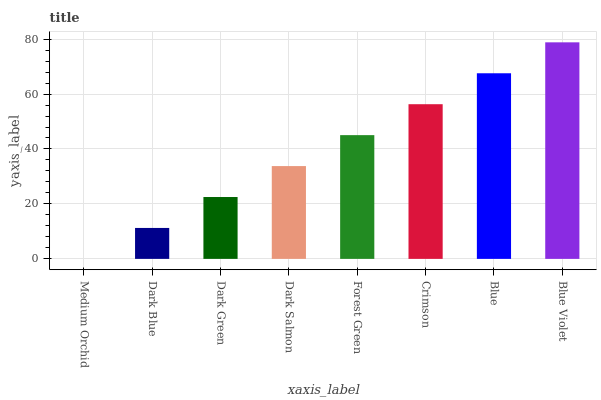Is Medium Orchid the minimum?
Answer yes or no. Yes. Is Blue Violet the maximum?
Answer yes or no. Yes. Is Dark Blue the minimum?
Answer yes or no. No. Is Dark Blue the maximum?
Answer yes or no. No. Is Dark Blue greater than Medium Orchid?
Answer yes or no. Yes. Is Medium Orchid less than Dark Blue?
Answer yes or no. Yes. Is Medium Orchid greater than Dark Blue?
Answer yes or no. No. Is Dark Blue less than Medium Orchid?
Answer yes or no. No. Is Forest Green the high median?
Answer yes or no. Yes. Is Dark Salmon the low median?
Answer yes or no. Yes. Is Dark Green the high median?
Answer yes or no. No. Is Blue Violet the low median?
Answer yes or no. No. 